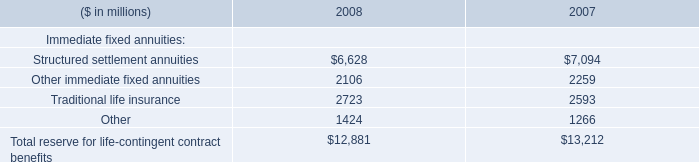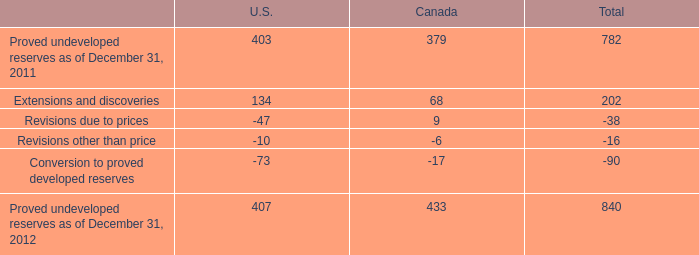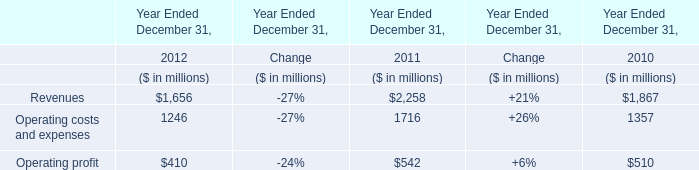What is the sum of the Revenues and the Operating profit in 2011 Ended December 31? (in million) 
Computations: (2258 + 542)
Answer: 2800.0. 